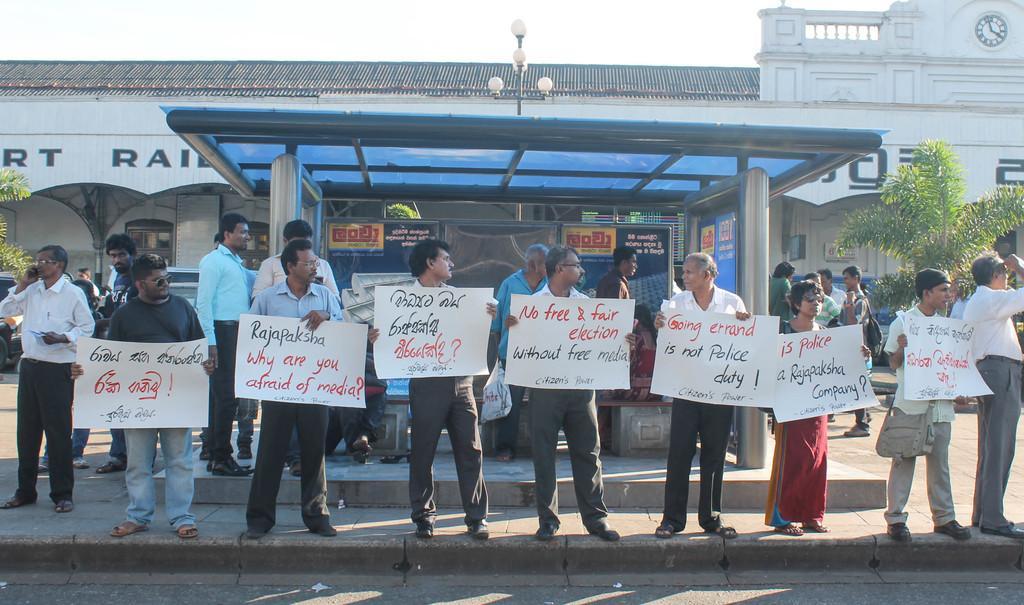Describe this image in one or two sentences. There are people those who are standing in series in the center of the image, by holding posters in their hands and there are people, vehicles, plants, lamp pole, shed and a building in the background are and there is sky at the top side. 